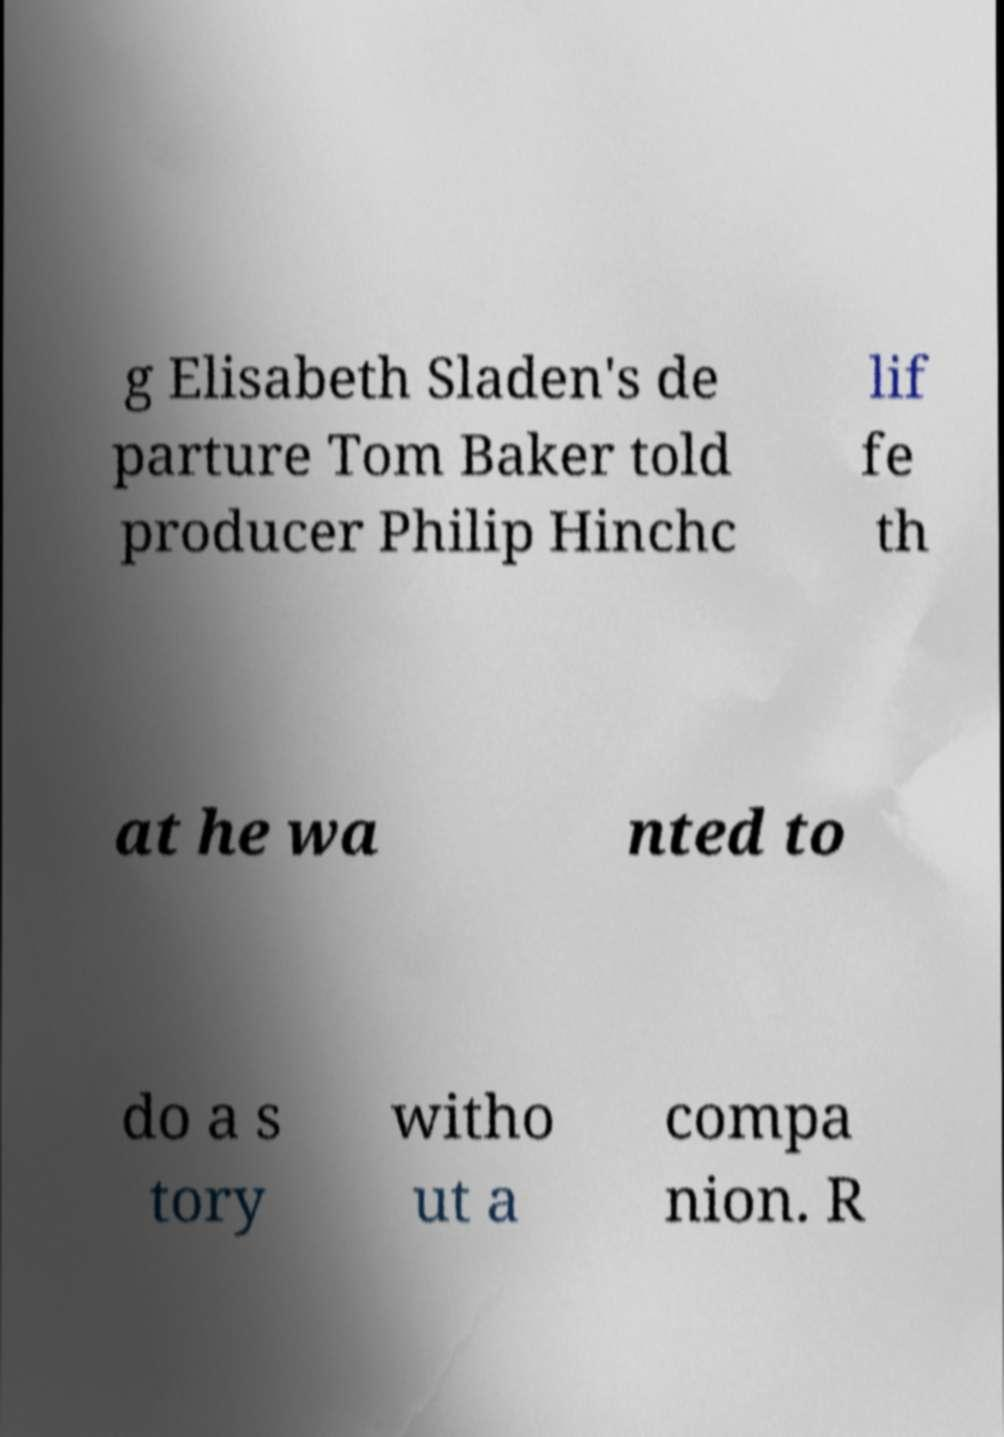Please read and relay the text visible in this image. What does it say? g Elisabeth Sladen's de parture Tom Baker told producer Philip Hinchc lif fe th at he wa nted to do a s tory witho ut a compa nion. R 